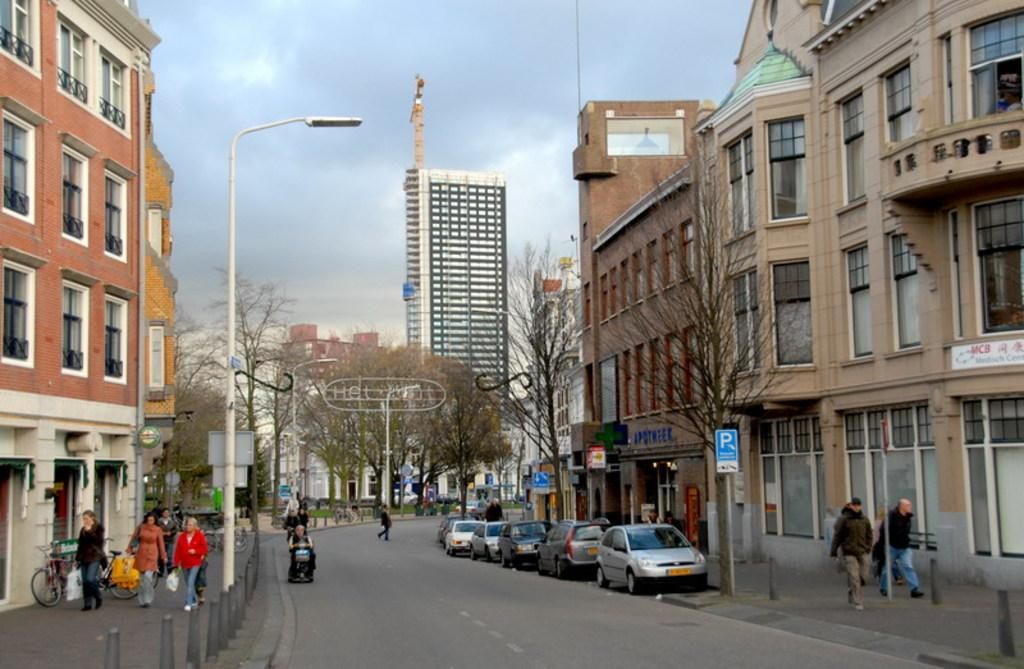What type of structures can be seen in the image? There are buildings in the image. What are the vehicles doing in the image? Cars are parked on the road in the image. What are the people doing in the image? People are walking on the sidewalk in the image, and one person is crossing the road. What can be seen on the streets to provide information or directions? There are sign boards in the image. How would you describe the weather based on the image? The sky is cloudy in the image. What type of wool is being used by the farmer in the image? There is no farmer or wool present in the image. What type of property is being sold on the sign boards in the image? The sign boards in the image provide information or directions, but they do not mention any property for sale. 